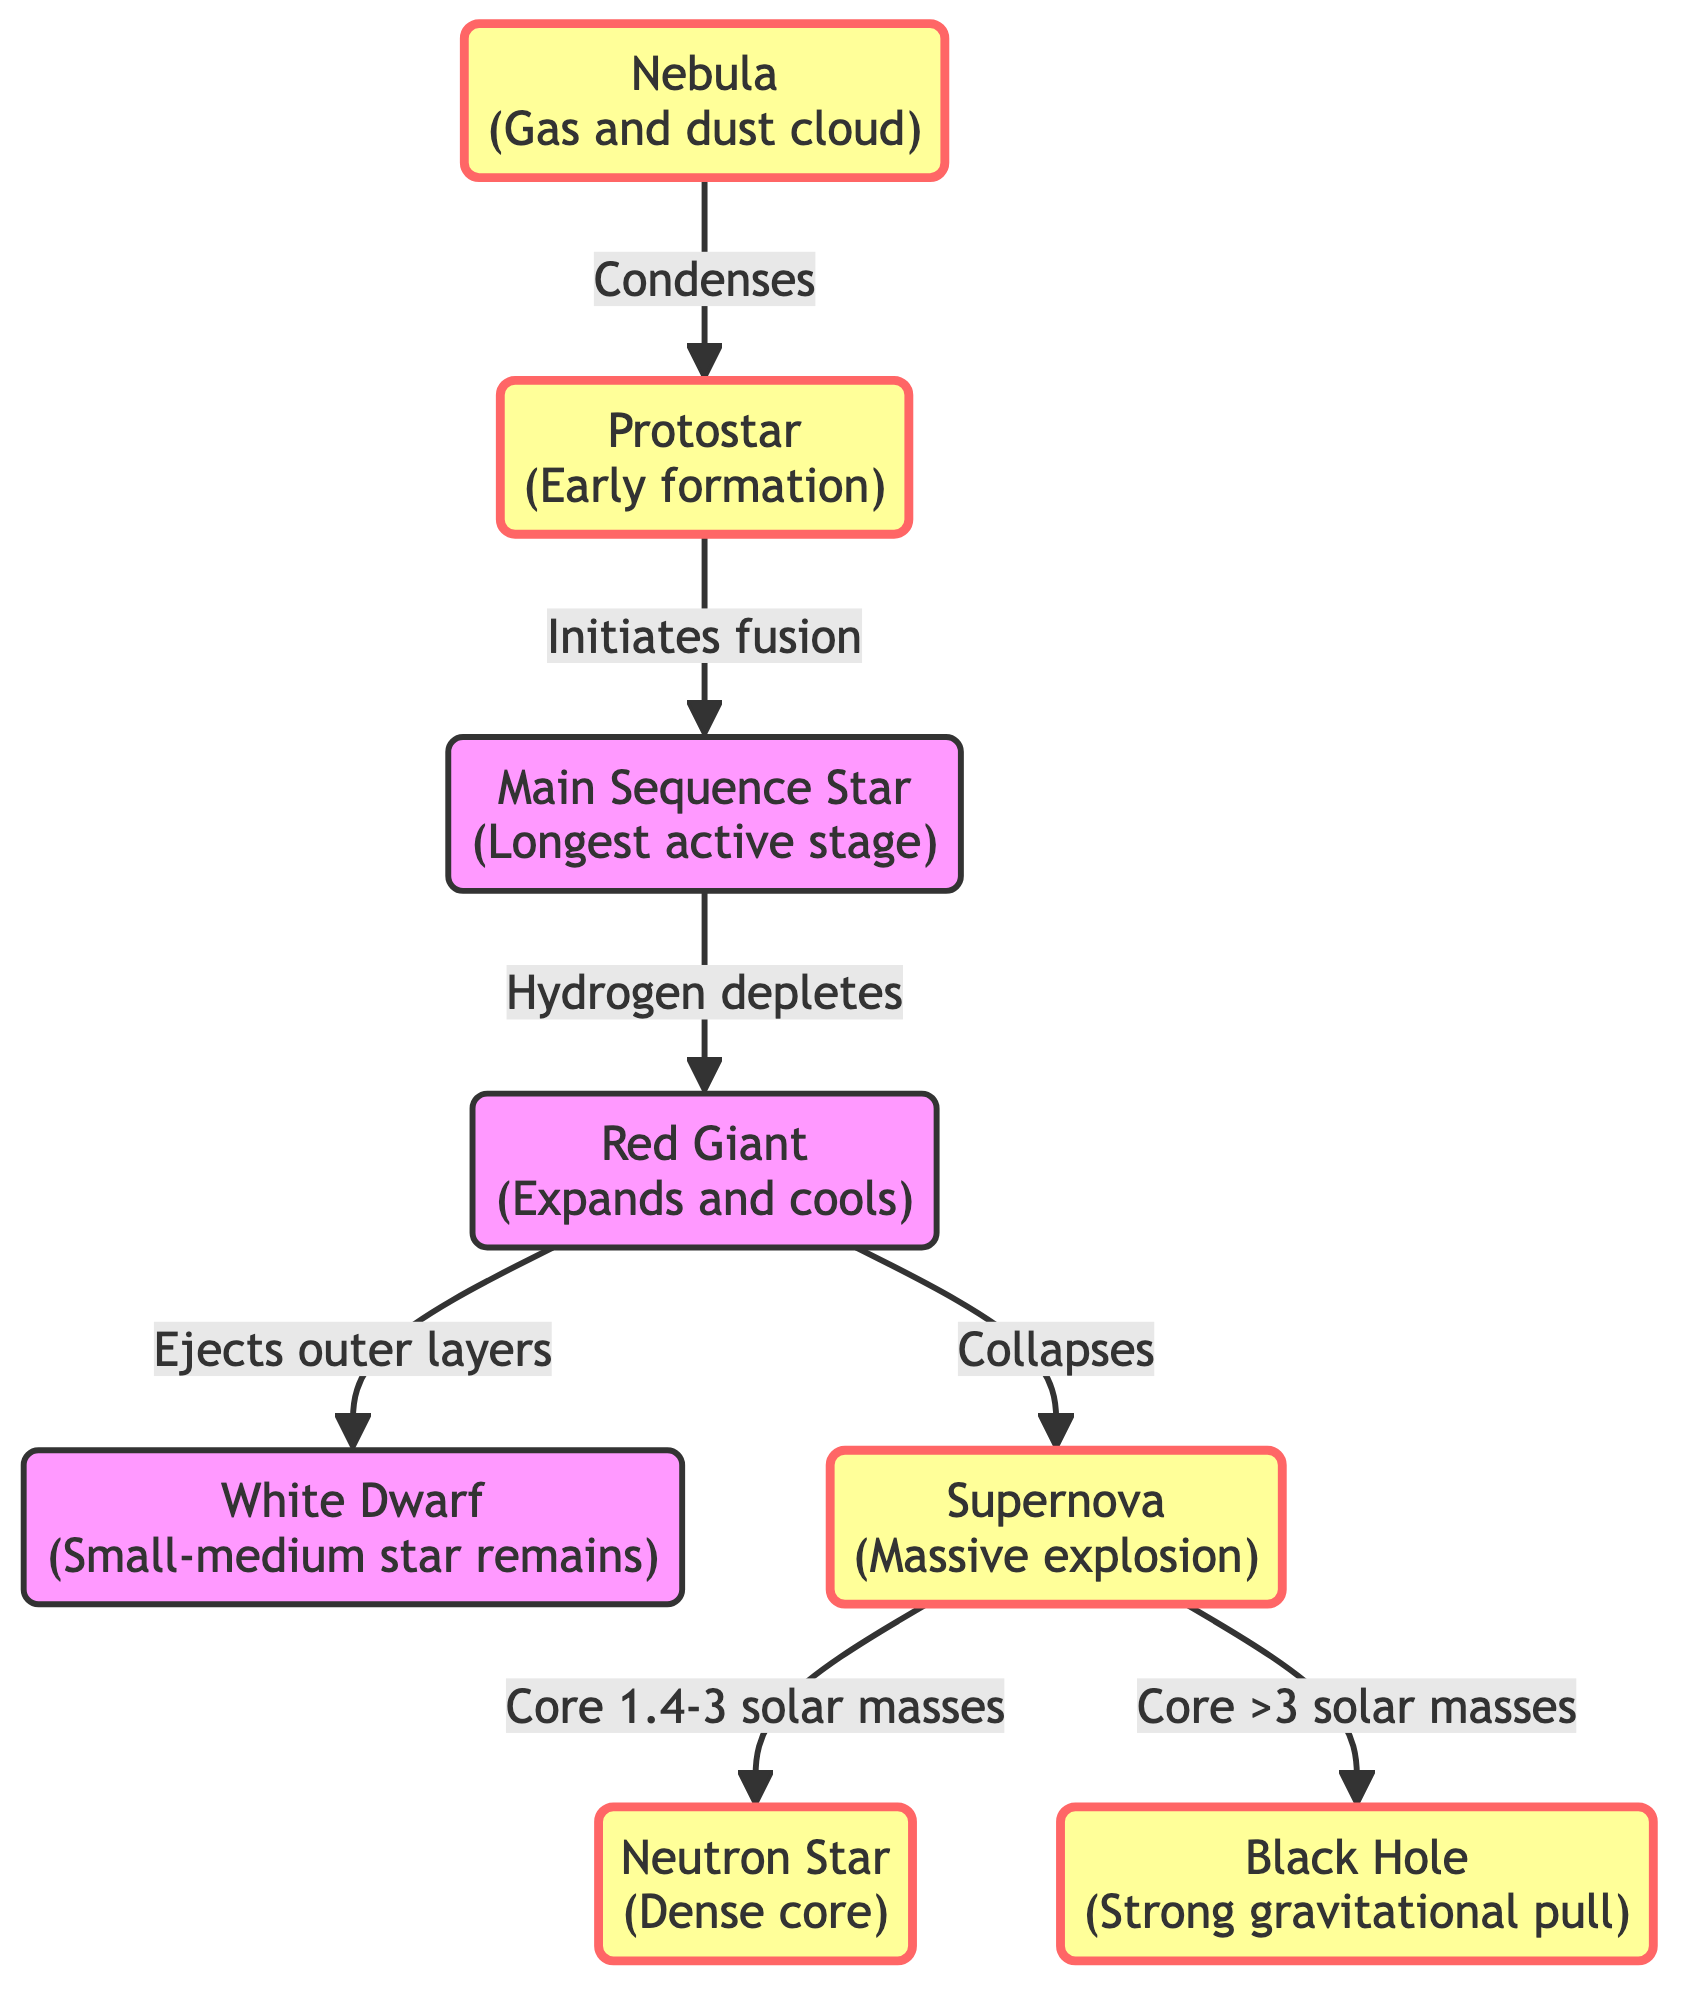What is the first stage in the star lifecycle? The diagram shows that the first stage is labeled "Nebula," which is a gas and dust cloud where stars begin their formation.
Answer: Nebula How many stages are there from birth to death in the star lifecycle? Counting the labeled stages in the diagram, there are a total of eight defined stages from Nebula to Black Hole, including all transitions.
Answer: 8 What happens to the main sequence star when hydrogen depletes? The diagram indicates that when hydrogen depletes in the main sequence star, it transitions into a red giant, expanding and cooling.
Answer: Red Giant Which two outcomes can occur after a supernova? The flowchart shows two potential outcomes from a supernova based on the mass of the core: it can become either a neutron star or a black hole, depending on whether the core is 1.4-3 solar masses or greater than 3 solar masses.
Answer: Neutron star or Black hole What is the relationship between the protostar and the main sequence star? According to the diagram, the protostar transitions into the main sequence star by initiating fusion, marking the start of the star’s stable burning phase.
Answer: Initiates fusion What stage comes after the red giant for small to medium stars? The diagram specifies that the red giant stage ejects its outer layers to leave a white dwarf, which is the next stage for small to medium stars.
Answer: White Dwarf What occurs to the outer layers of a red giant? The diagram describes that the red giant stage ejects its outer layers, which is a significant process of moving to subsequent stages of stellar evolution.
Answer: Ejects outer layers What is the characteristic of a neutron star depicted in the diagram? In the diagram, the neutron star is characterized as having a dense core, which is a result of the gravitational collapse following a supernova for specific mass ranges.
Answer: Dense core 